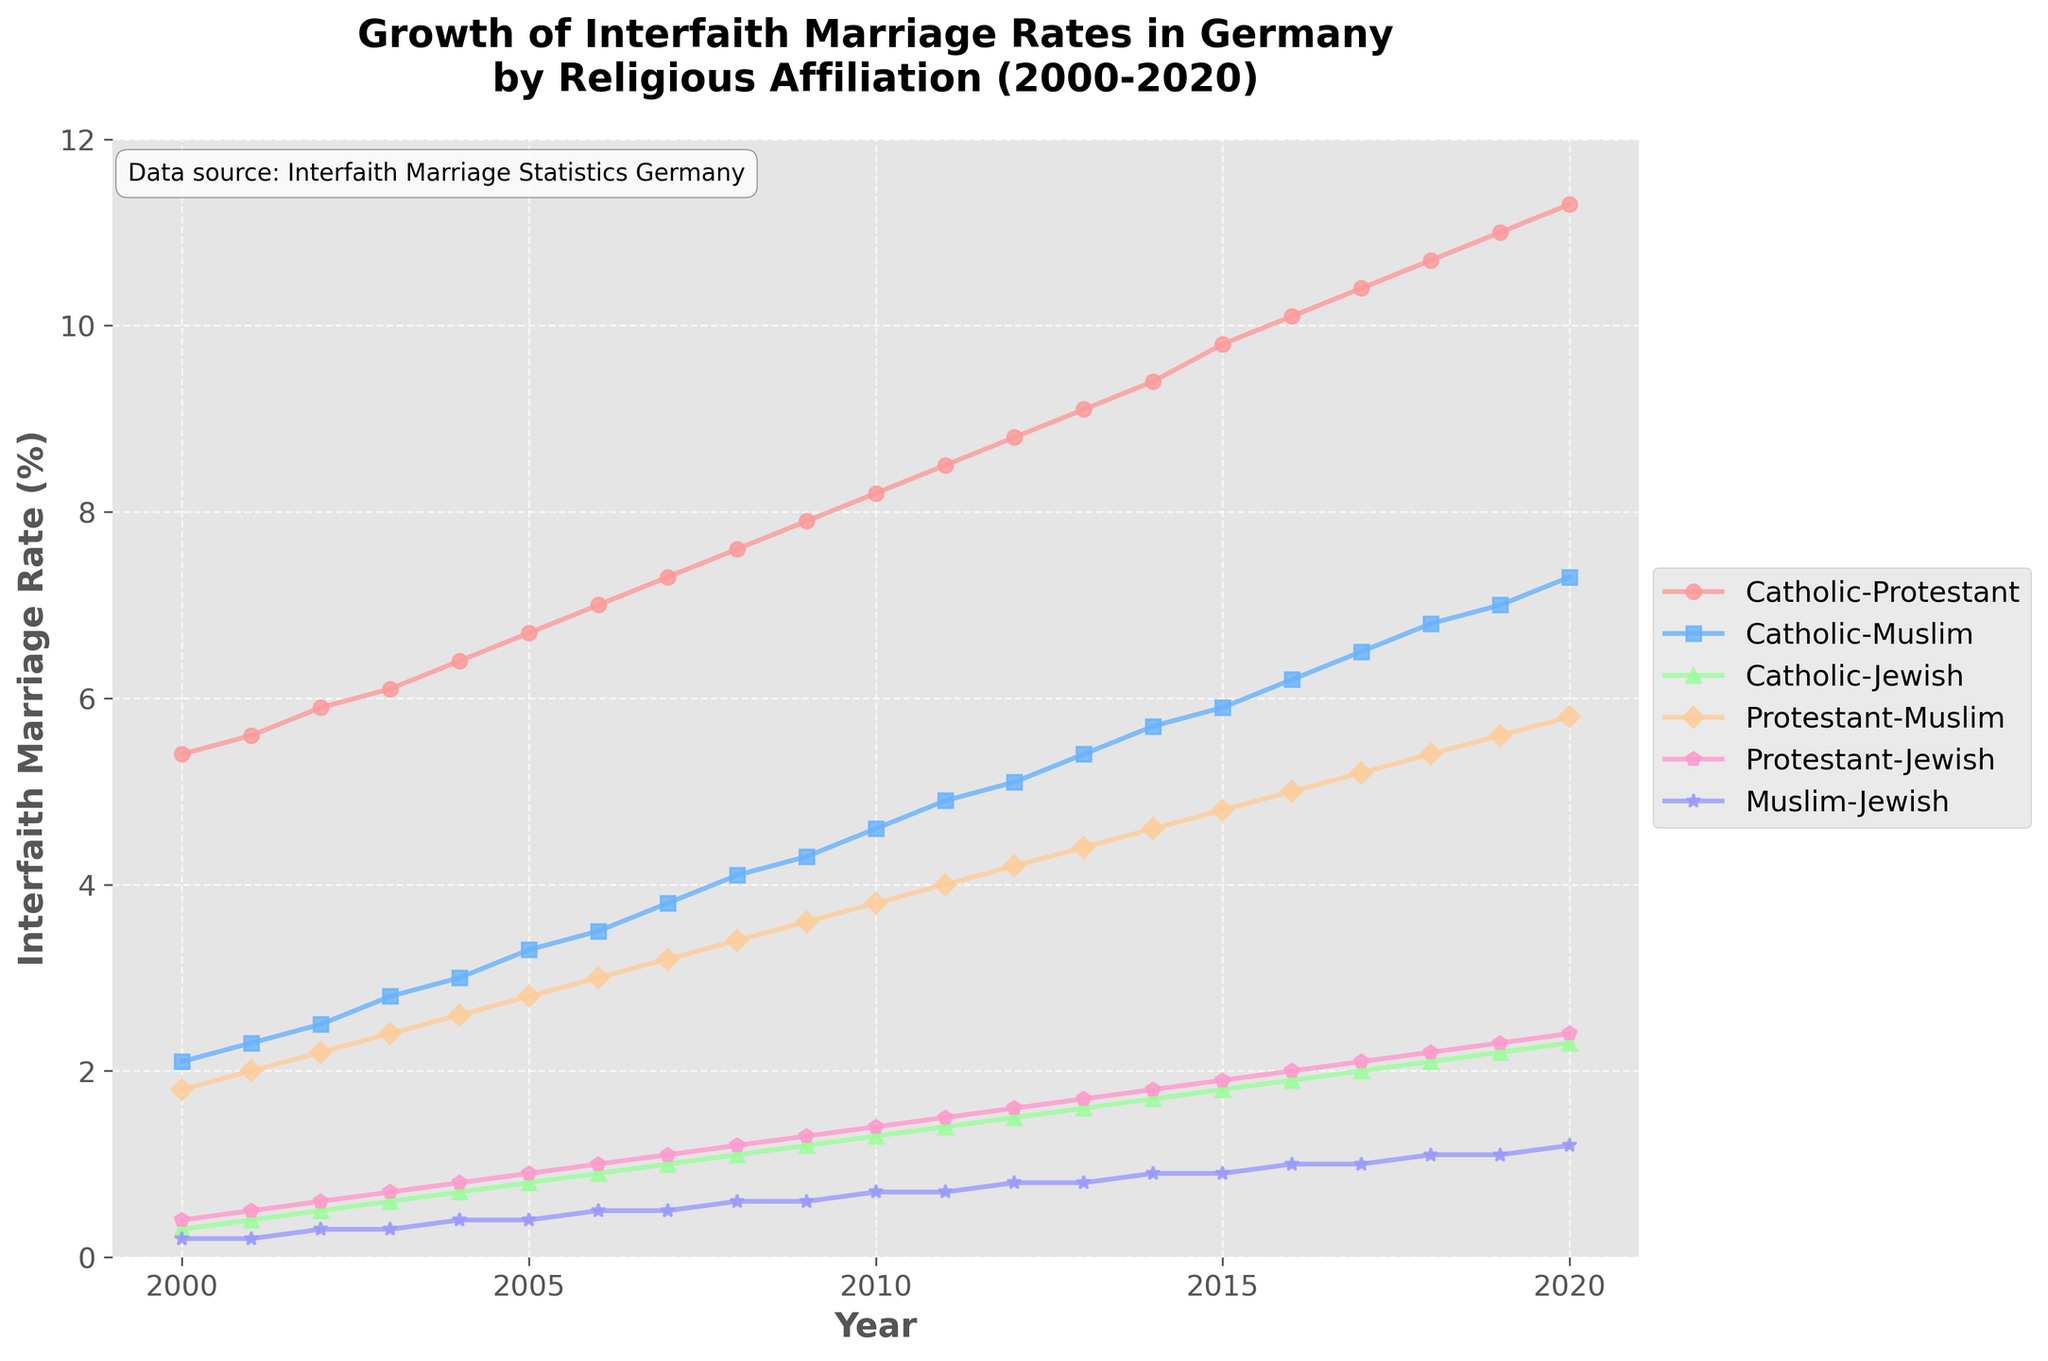What is the title of the plot? The plot title can be found at the top of the figure. It reads, 'Growth of Interfaith Marriage Rates in Germany by Religious Affiliation (2000-2020).'
Answer: Growth of Interfaith Marriage Rates in Germany by Religious Affiliation (2000-2020) Which interfaith marriage rate was the highest in 2020? To find this, observe the data points for each group in the year 2020 and compare their values. The highest rate is for Catholic-Protestant, which is 11.3%.
Answer: Catholic-Protestant What is the trend of the Catholic-Muslim marriage rate from 2000 to 2020? The Catholic-Muslim marriage rate increases steadily from around 2.1% in 2000 to 7.3% in 2020, showing a consistent upward trend.
Answer: Increasing trend Compare the Catholic-Jewish and Muslim-Jewish rates in 2010. Which one is higher and by how much? Locate the data points for 2010 for both groups. Catholic-Jewish is at 1.3% while Muslim-Jewish is at 0.7%. The difference is 1.3% - 0.7% = 0.6%.
Answer: Catholic-Jewish by 0.6% By how much did the Protestant-Muslim marriage rate increase from 2000 to 2020? Find the values for 2000 (1.8%) and 2020 (5.8%). Subtract the 2000 value from the 2020 value: 5.8% - 1.8% = 4.0%.
Answer: 4.0% What year did the Protestant-Jewish marriage rate first exceed 2%? Identify the year where the graph of Protestant-Jewish first crosses the 2% mark. It exceeds 2% in 2017.
Answer: 2017 Which interfaith marriage rate showed the smallest increase over the 20-year period? To find the smallest increase, calculate the difference between 2020 and 2000 for each rate. Muslim-Jewish increases from 0.2% to 1.2%, a change of 1.0%, which is the smallest.
Answer: Muslim-Jewish How does the Catholic-Protestant rate in 2005 compare to the Protestant-Muslim rate in 2015? Compare the Catholic-Protestant rate in 2005 (6.7%) to the Protestant-Muslim rate in 2015 (4.8%). The Catholic-Protestant rate is higher.
Answer: Catholic-Protestant is higher What noticeable pattern can you observe in the Protestant-Jewish marriage rate trend? The Protestant-Jewish marriage rate shows a steady and consistent increase from about 0.4% in 2000 to 2.4% in 2020 without any declines.
Answer: Steady increase What is the approximate average annual growth rate for the Catholic-Muslim interfaith marriages from 2000 to 2020? Calculate the total increase (7.3% - 2.1% = 5.2%) and divide by the number of years (2020 - 2000 = 20 years): 5.2% / 20 years = 0.26% per year.
Answer: 0.26% per year 